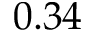Convert formula to latex. <formula><loc_0><loc_0><loc_500><loc_500>0 . 3 4</formula> 